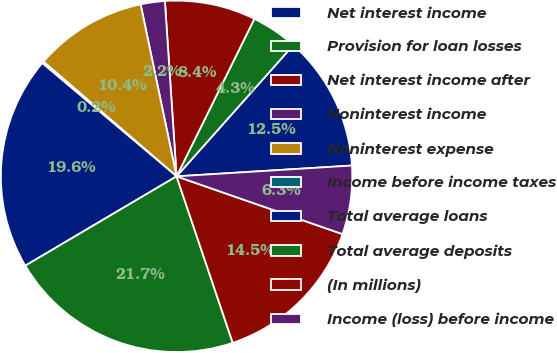Convert chart to OTSL. <chart><loc_0><loc_0><loc_500><loc_500><pie_chart><fcel>Net interest income<fcel>Provision for loan losses<fcel>Net interest income after<fcel>Noninterest income<fcel>Noninterest expense<fcel>Income before income taxes<fcel>Total average loans<fcel>Total average deposits<fcel>(In millions)<fcel>Income (loss) before income<nl><fcel>12.45%<fcel>4.27%<fcel>8.36%<fcel>2.22%<fcel>10.4%<fcel>0.17%<fcel>19.64%<fcel>21.69%<fcel>14.49%<fcel>6.31%<nl></chart> 